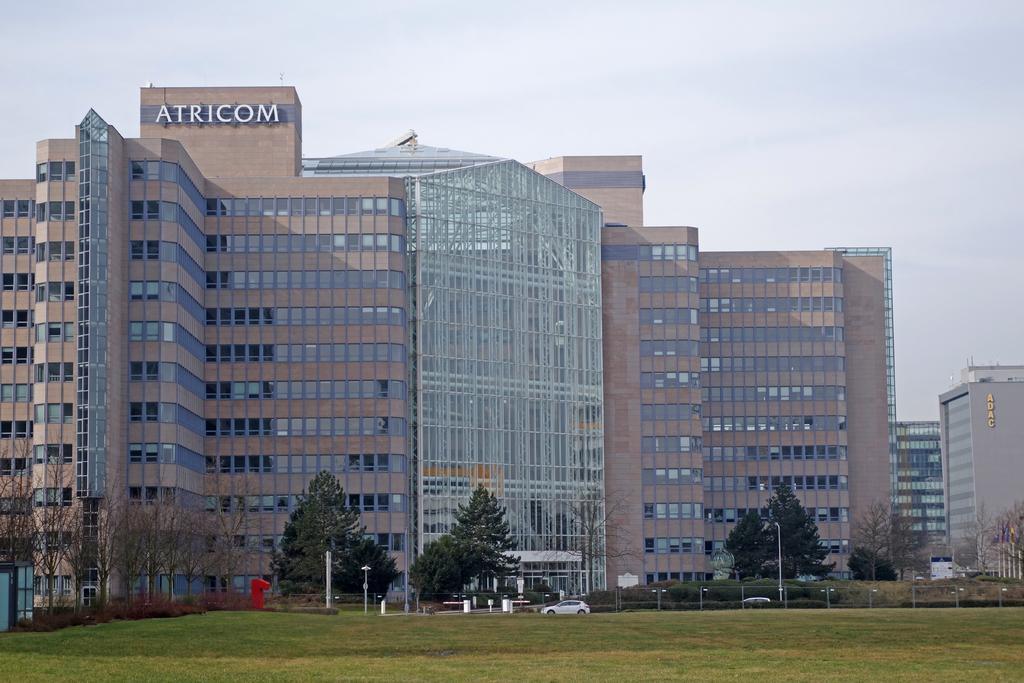Can you describe this image briefly? In this picture I can see few buildings, some vehicles in front of the buildings, around there are some trees and grass. 